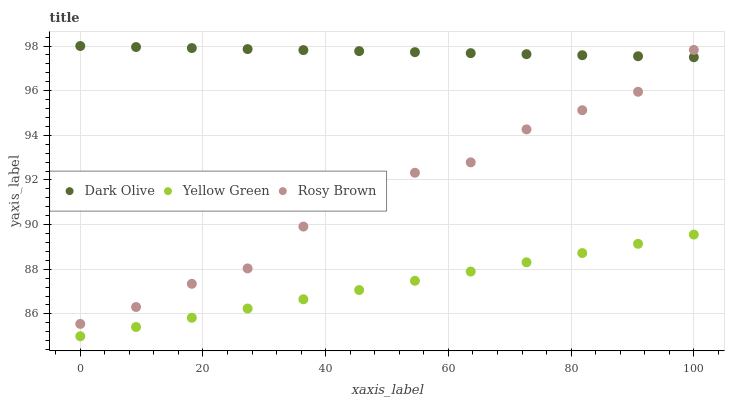Does Yellow Green have the minimum area under the curve?
Answer yes or no. Yes. Does Dark Olive have the maximum area under the curve?
Answer yes or no. Yes. Does Dark Olive have the minimum area under the curve?
Answer yes or no. No. Does Yellow Green have the maximum area under the curve?
Answer yes or no. No. Is Yellow Green the smoothest?
Answer yes or no. Yes. Is Rosy Brown the roughest?
Answer yes or no. Yes. Is Dark Olive the smoothest?
Answer yes or no. No. Is Dark Olive the roughest?
Answer yes or no. No. Does Yellow Green have the lowest value?
Answer yes or no. Yes. Does Dark Olive have the lowest value?
Answer yes or no. No. Does Dark Olive have the highest value?
Answer yes or no. Yes. Does Yellow Green have the highest value?
Answer yes or no. No. Is Yellow Green less than Rosy Brown?
Answer yes or no. Yes. Is Dark Olive greater than Yellow Green?
Answer yes or no. Yes. Does Rosy Brown intersect Dark Olive?
Answer yes or no. Yes. Is Rosy Brown less than Dark Olive?
Answer yes or no. No. Is Rosy Brown greater than Dark Olive?
Answer yes or no. No. Does Yellow Green intersect Rosy Brown?
Answer yes or no. No. 